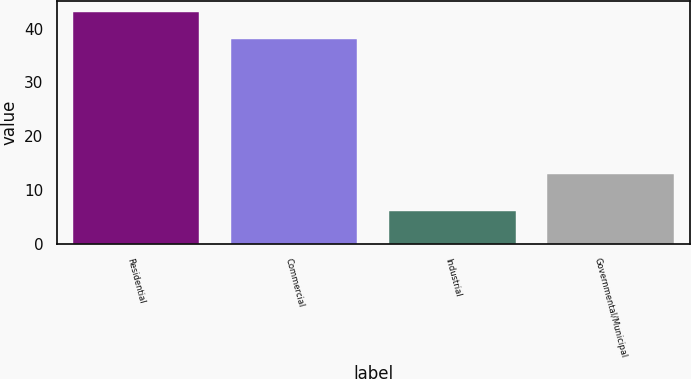Convert chart to OTSL. <chart><loc_0><loc_0><loc_500><loc_500><bar_chart><fcel>Residential<fcel>Commercial<fcel>Industrial<fcel>Governmental/Municipal<nl><fcel>43<fcel>38<fcel>6<fcel>13<nl></chart> 